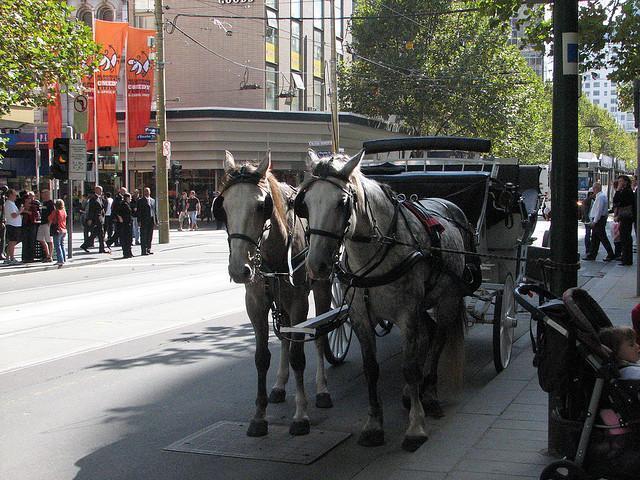What turn is forbidden?
Indicate the correct response and explain using: 'Answer: answer
Rationale: rationale.'
Options: U-turn, right turn, left turn, straightaway. Answer: left turn.
Rationale: They can not turn left. 